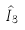<formula> <loc_0><loc_0><loc_500><loc_500>\hat { I } _ { 3 }</formula> 